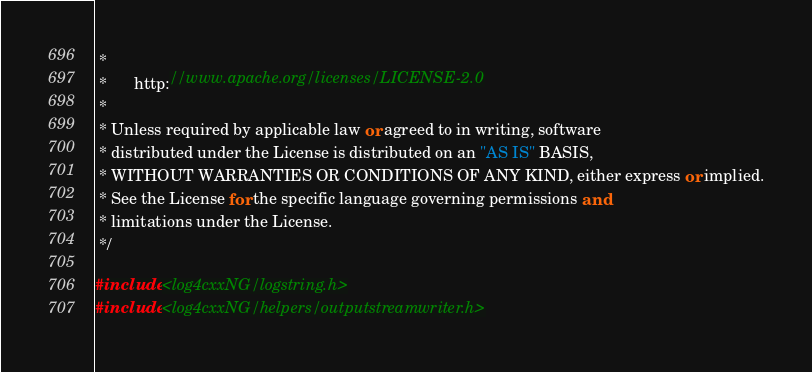Convert code to text. <code><loc_0><loc_0><loc_500><loc_500><_C++_> *
 *      http://www.apache.org/licenses/LICENSE-2.0
 *
 * Unless required by applicable law or agreed to in writing, software
 * distributed under the License is distributed on an "AS IS" BASIS,
 * WITHOUT WARRANTIES OR CONDITIONS OF ANY KIND, either express or implied.
 * See the License for the specific language governing permissions and
 * limitations under the License.
 */

#include <log4cxxNG/logstring.h>
#include <log4cxxNG/helpers/outputstreamwriter.h></code> 